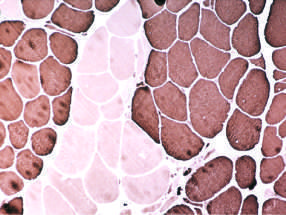do large clusters of fibers appear that all share the same fiber type (fiber type grouping) with ongoing denervation and reinnervation?
Answer the question using a single word or phrase. Yes 